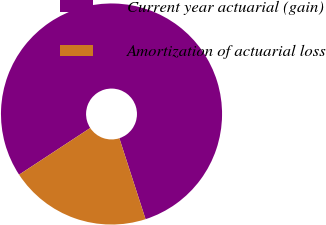<chart> <loc_0><loc_0><loc_500><loc_500><pie_chart><fcel>Current year actuarial (gain)<fcel>Amortization of actuarial loss<nl><fcel>79.26%<fcel>20.74%<nl></chart> 